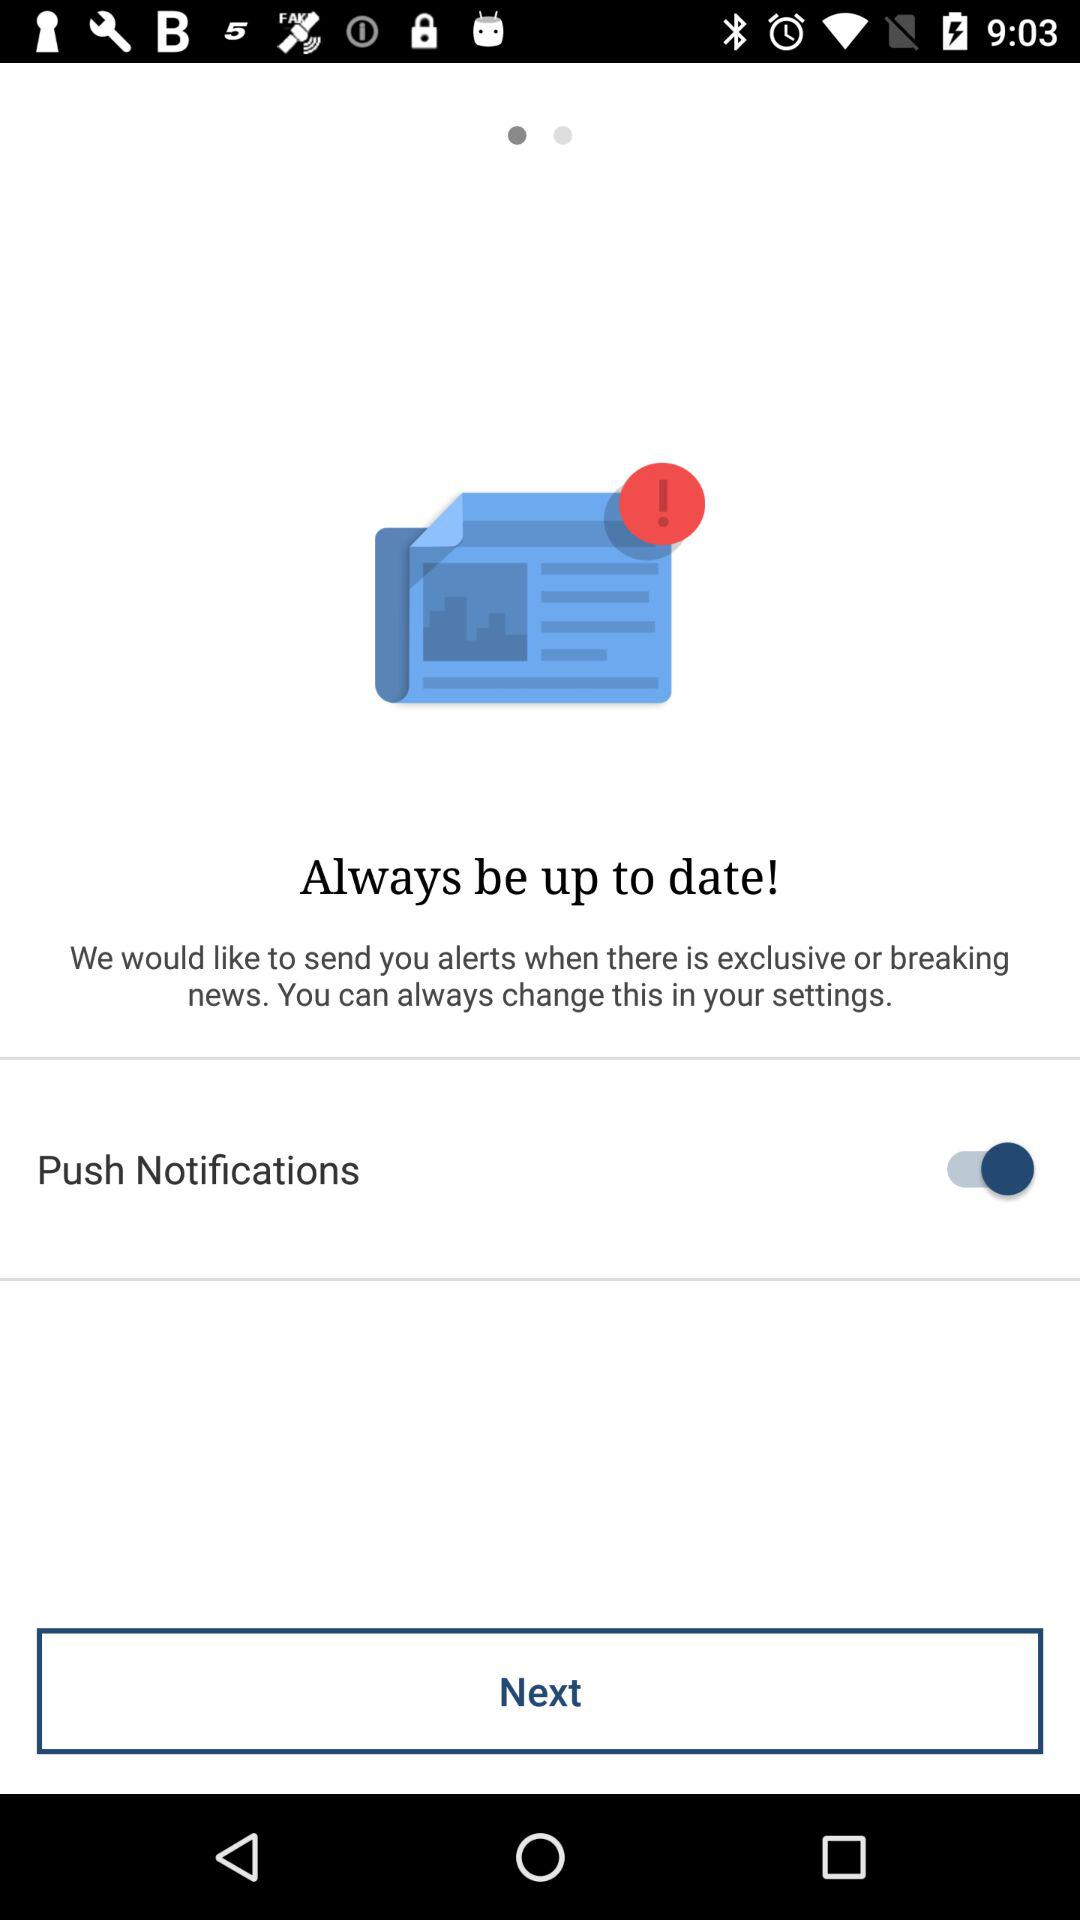What is the status of the push notifications? The status is on. 